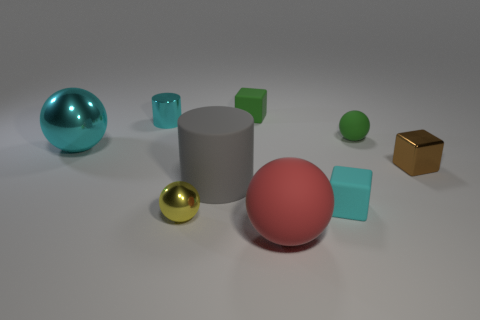Subtract all tiny green matte blocks. How many blocks are left? 2 Subtract all gray cylinders. How many cylinders are left? 1 Subtract all cubes. How many objects are left? 6 Subtract 1 cylinders. How many cylinders are left? 1 Subtract all brown spheres. Subtract all red cubes. How many spheres are left? 4 Subtract all cylinders. Subtract all small cyan blocks. How many objects are left? 6 Add 3 big balls. How many big balls are left? 5 Add 8 tiny brown shiny cubes. How many tiny brown shiny cubes exist? 9 Subtract 0 purple balls. How many objects are left? 9 